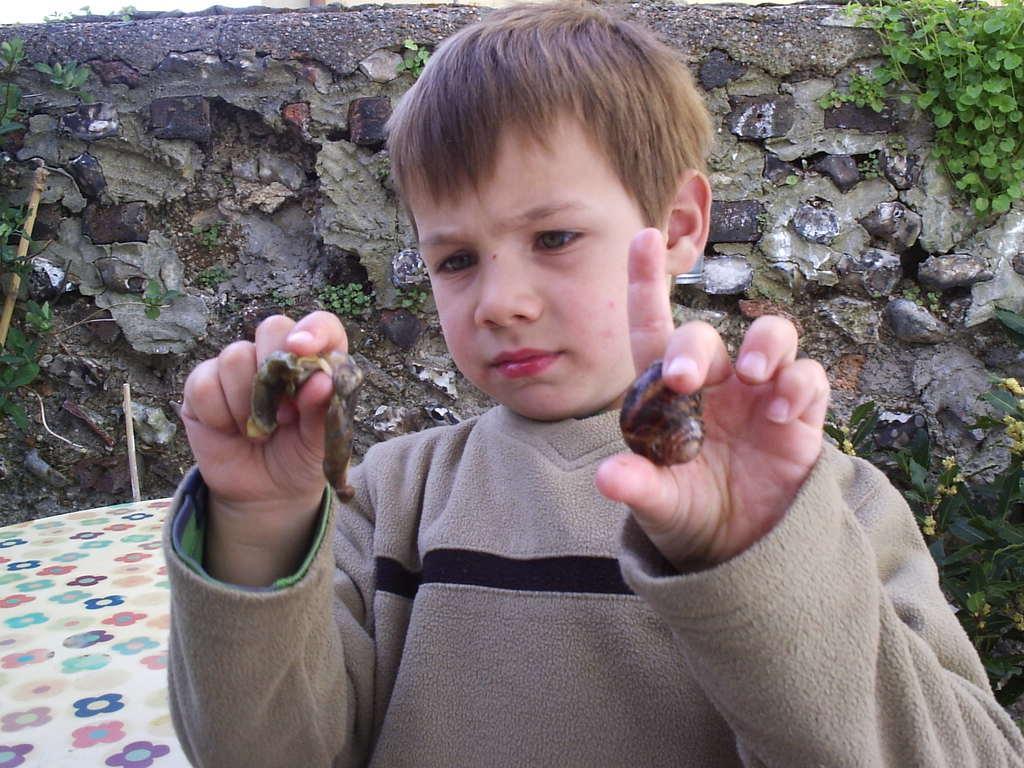In one or two sentences, can you explain what this image depicts? In this picture there is a kid holding an insect in one of his hand and a snail shell in his another hand and there is a stone wall behind him. 